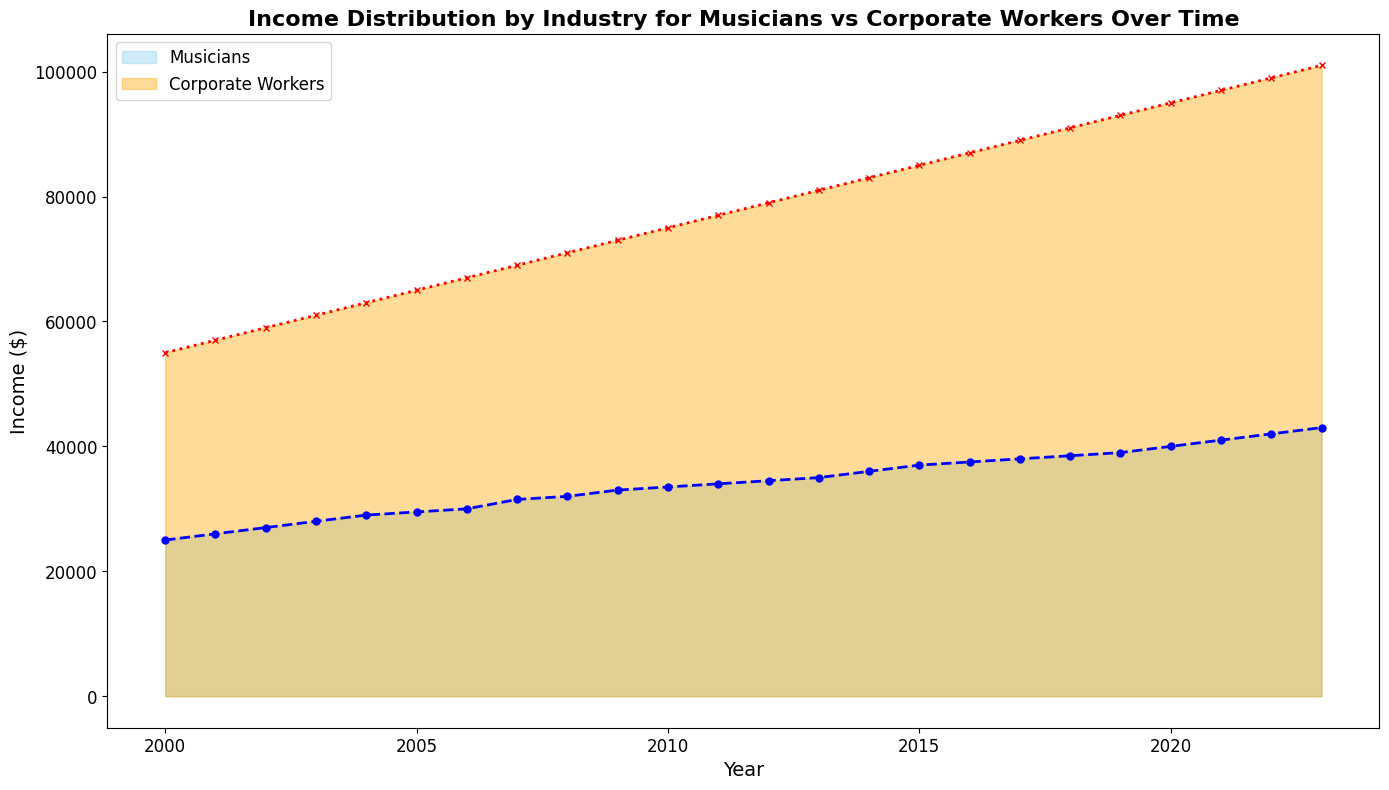What is the difference in income between musicians and corporate workers in the year 2023? To find the difference, subtract the income of musicians from the income of corporate workers for the year 2023. So, 101000 - 43000 = 58000
Answer: 58000 In which year did corporate workers' income reach $85000? Looking at the plot, follow the orange line for corporate workers' income and identify the year when it crosses the $85000 mark. This happens in the year 2015.
Answer: 2015 How much did musicians' income increase from 2000 to 2023? To determine the increase, subtract the income of musicians in 2000 from their income in 2023. So, 43000 - 25000 = 18000
Answer: 18000 By how much did the income gap between musicians and corporate workers grow from 2000 to 2023? First, find the income gap in 2000: 55000 - 25000 = 30000. Next, find the income gap in 2023: 101000 - 43000 = 58000. Finally, subtract the gap in 2000 from the gap in 2023: 58000 - 30000 = 28000
Answer: 28000 What was the average income of corporate workers between 2010 and 2020? To calculate the average, add the incomes of corporate workers from 2010 to 2020 and then divide by the number of years. \((75000 + 77000 + 79000 + 81000 + 83000 + 85000 + 87000 + 89000 + 91000 + 93000 + 95000) / 11 = 84500\)
Answer: 84500 Which group had a higher income in 2007, and by how much? Comparing the plot points for the year 2007, corporate workers had an income of 69000, whereas musicians had an income of 31500. The difference is 69000 - 31500 = 37500
Answer: Corporate workers, 37500 What visual cues indicate the trend of income growth for both groups? The area chart shows both groups' income with distinct colors: skyblue for musicians and orange for corporate workers. The plotted lines, marked with blue circles and red crosses, indicate a continuous upward trend for both groups, with corporate workers consistently growing at a faster rate.
Answer: Upward trend indicated by increasing height of filled areas and lines By what percentage did the income of musicians increase between 2010 and 2020? First, find the difference in income between 2010 and 2020 for musicians: 40000 - 33500 = 6500. Then, calculate the percentage increase: (6500 / 33500) * 100 = 19.4%
Answer: 19.4% Between which consecutive years did musicians experience the highest income increase? Analyze the plot and note the increments year by year for musicians. The highest increase is between 2022 and 2023, where the income rose from 42000 to 43000, a 1000 dollar increase.
Answer: 2022-2023 